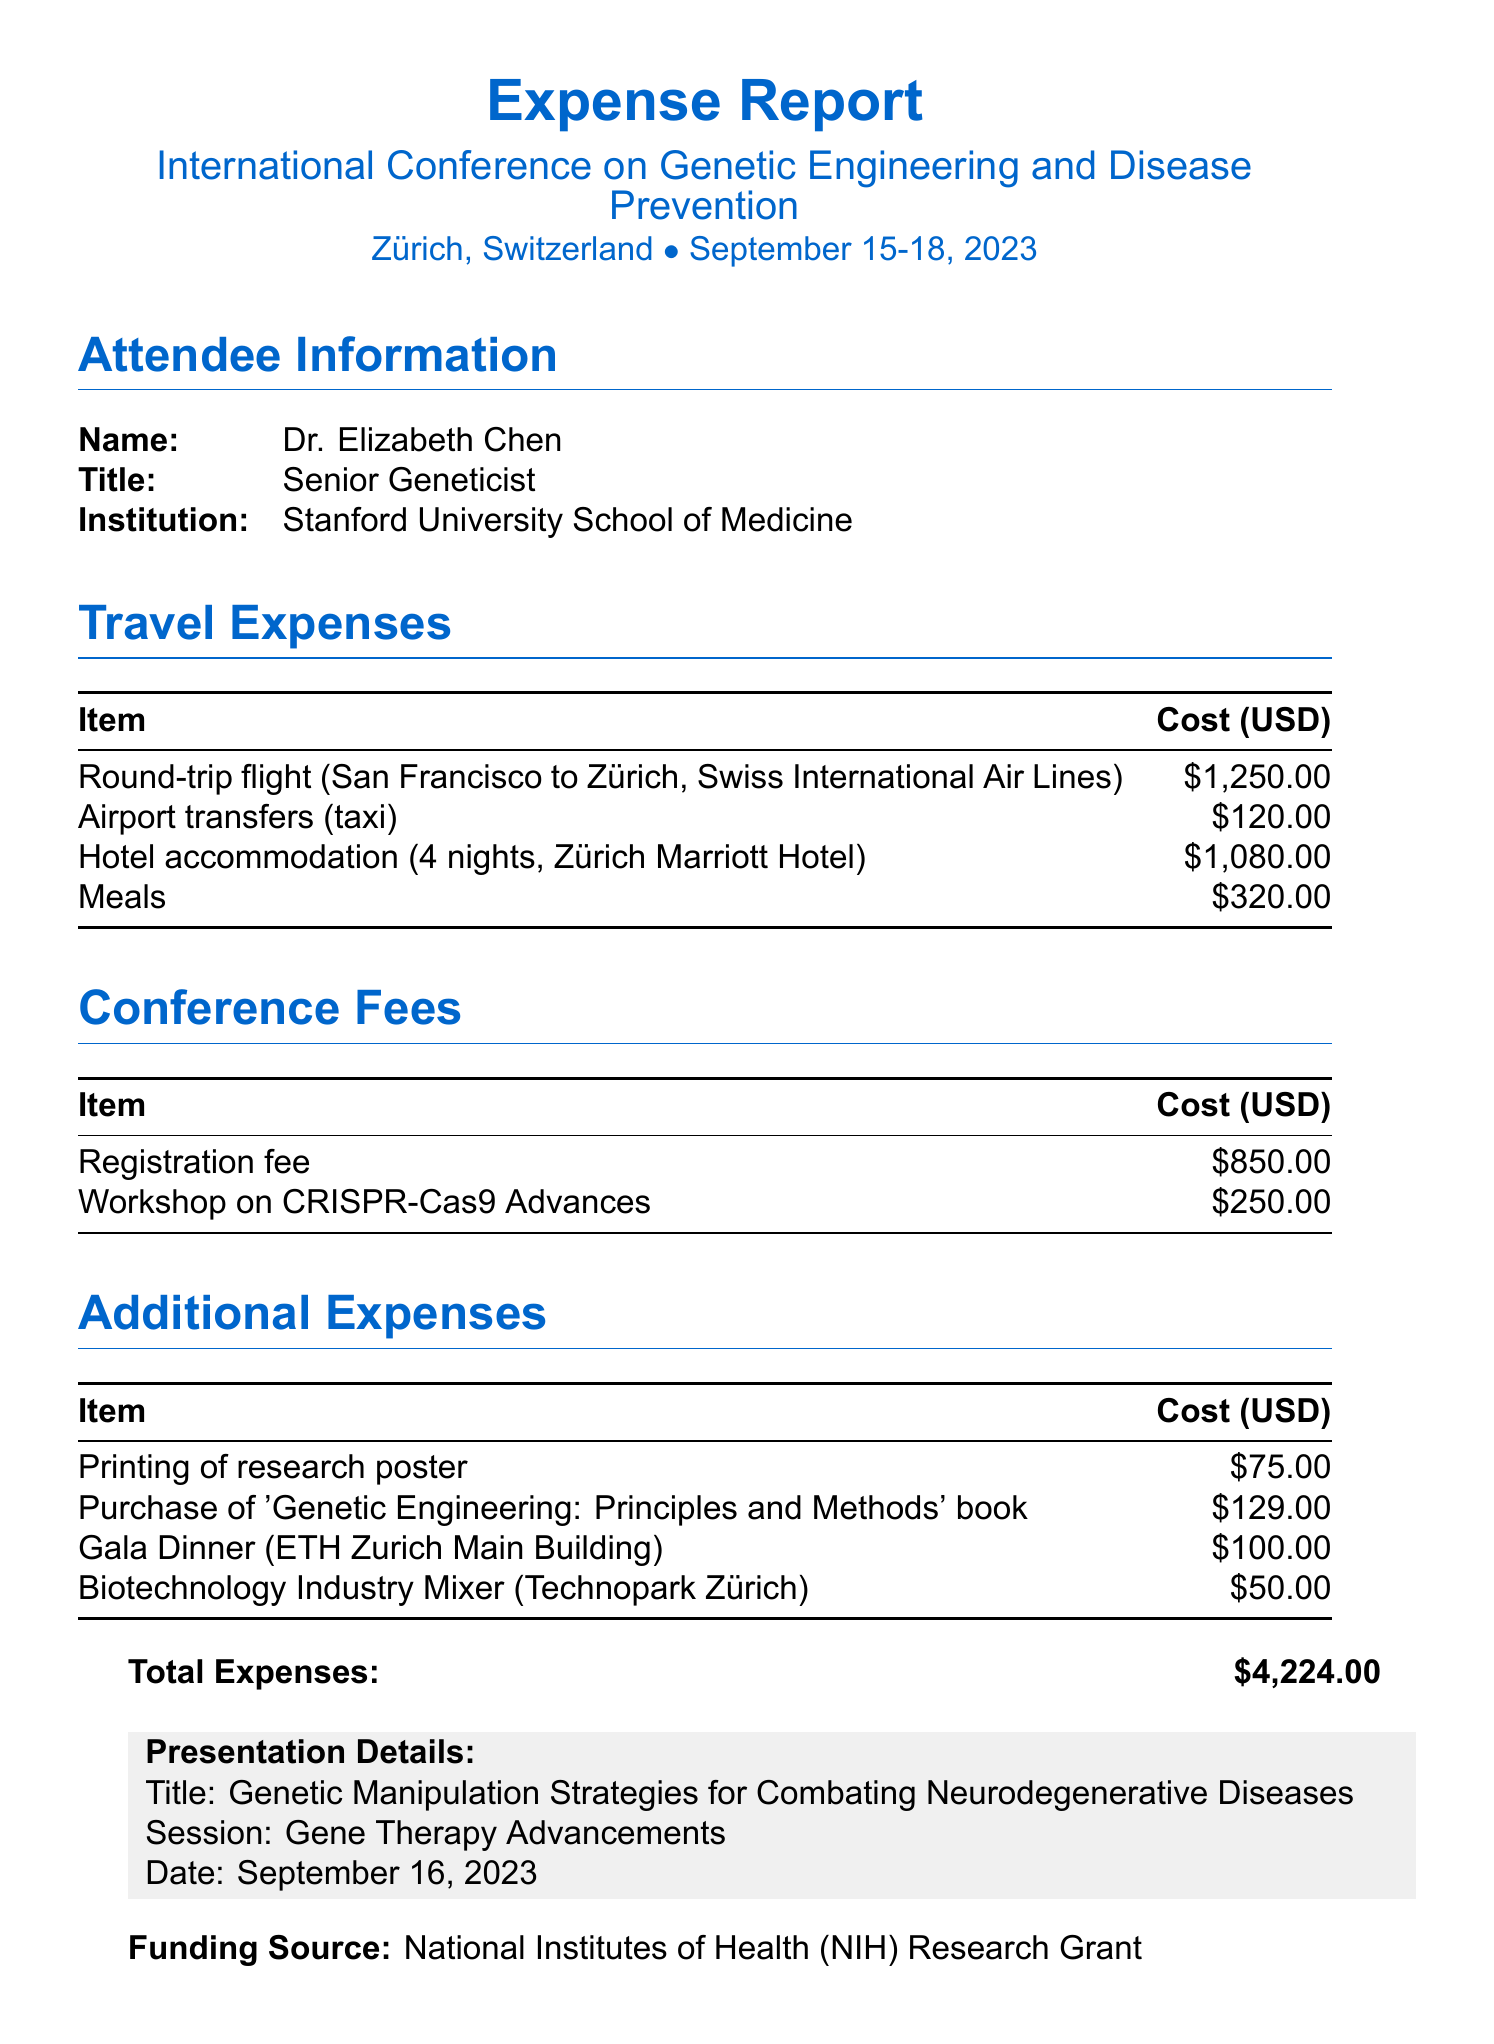What is the name of the conference? The name of the conference is explicitly mentioned in the document as "International Conference on Genetic Engineering and Disease Prevention."
Answer: International Conference on Genetic Engineering and Disease Prevention Where is the conference located? The document details the location of the conference as "Zürich, Switzerland."
Answer: Zürich, Switzerland What are the conference dates? The conference dates are stated in the document as "September 15-18, 2023."
Answer: September 15-18, 2023 Who is the attendee? The attendee's information is provided in the document, showing the name as "Dr. Elizabeth Chen."
Answer: Dr. Elizabeth Chen How much was spent on hotel accommodation? The document lists the cost for hotel accommodation, which is "1080.00."
Answer: 1080.00 What is the total expense of the conference? The total expense is explicitly calculated and mentioned in the document as "4224.00."
Answer: 4224.00 What title did Dr. Elizabeth Chen present? The document specifies the presentation title as "Genetic Manipulation Strategies for Combating Neurodegenerative Diseases."
Answer: Genetic Manipulation Strategies for Combating Neurodegenerative Diseases What was one of the networking events attended? The document lists networking events, one of which is the "Gala Dinner."
Answer: Gala Dinner Who approved the expenses? The expense approver is identified in the document as "Dr. Michael Thompson."
Answer: Dr. Michael Thompson 